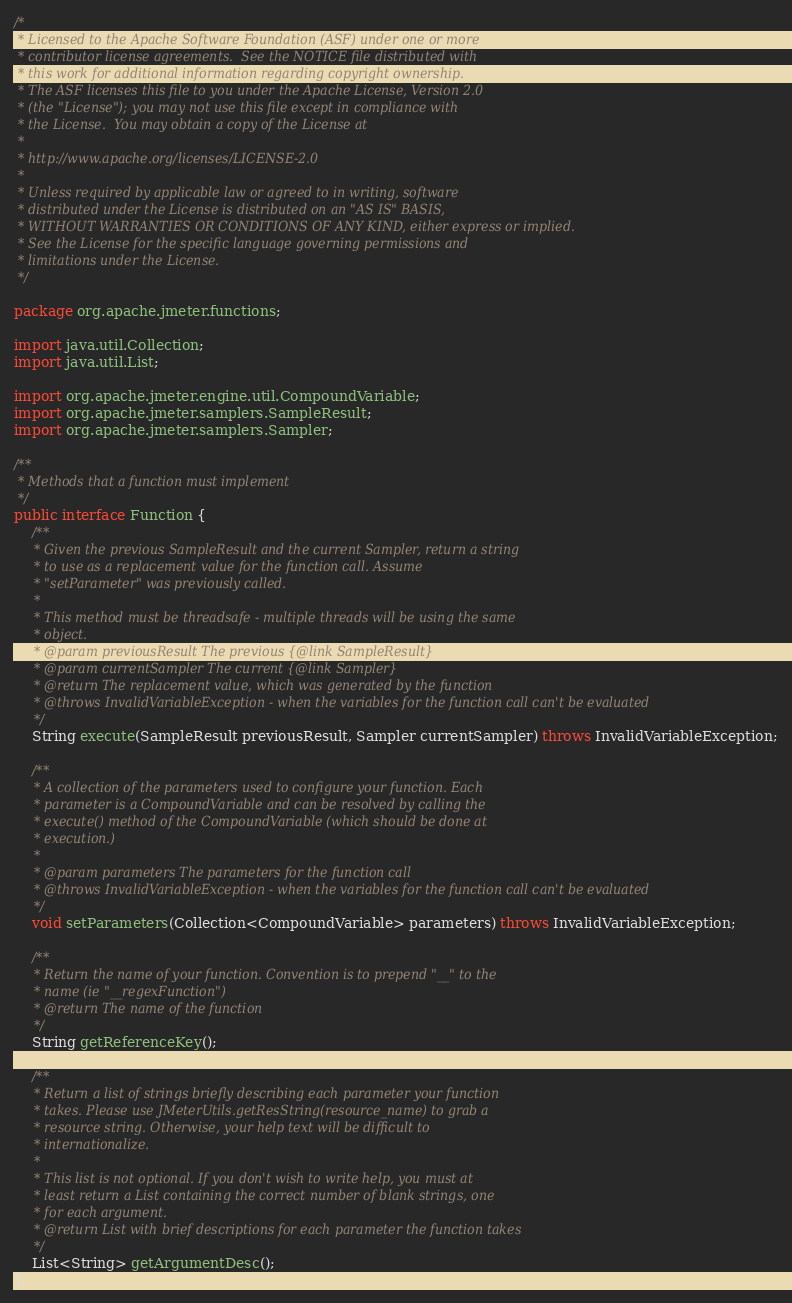<code> <loc_0><loc_0><loc_500><loc_500><_Java_>/*
 * Licensed to the Apache Software Foundation (ASF) under one or more
 * contributor license agreements.  See the NOTICE file distributed with
 * this work for additional information regarding copyright ownership.
 * The ASF licenses this file to you under the Apache License, Version 2.0
 * (the "License"); you may not use this file except in compliance with
 * the License.  You may obtain a copy of the License at
 *
 * http://www.apache.org/licenses/LICENSE-2.0
 *
 * Unless required by applicable law or agreed to in writing, software
 * distributed under the License is distributed on an "AS IS" BASIS,
 * WITHOUT WARRANTIES OR CONDITIONS OF ANY KIND, either express or implied.
 * See the License for the specific language governing permissions and
 * limitations under the License.
 */

package org.apache.jmeter.functions;

import java.util.Collection;
import java.util.List;

import org.apache.jmeter.engine.util.CompoundVariable;
import org.apache.jmeter.samplers.SampleResult;
import org.apache.jmeter.samplers.Sampler;

/**
 * Methods that a function must implement
 */
public interface Function {
    /**
     * Given the previous SampleResult and the current Sampler, return a string
     * to use as a replacement value for the function call. Assume
     * "setParameter" was previously called.
     *
     * This method must be threadsafe - multiple threads will be using the same
     * object.
     * @param previousResult The previous {@link SampleResult}
     * @param currentSampler The current {@link Sampler}
     * @return The replacement value, which was generated by the function
     * @throws InvalidVariableException - when the variables for the function call can't be evaluated
     */
    String execute(SampleResult previousResult, Sampler currentSampler) throws InvalidVariableException;

    /**
     * A collection of the parameters used to configure your function. Each
     * parameter is a CompoundVariable and can be resolved by calling the
     * execute() method of the CompoundVariable (which should be done at
     * execution.)
     *
     * @param parameters The parameters for the function call
     * @throws InvalidVariableException - when the variables for the function call can't be evaluated
     */
    void setParameters(Collection<CompoundVariable> parameters) throws InvalidVariableException;

    /**
     * Return the name of your function. Convention is to prepend "__" to the
     * name (ie "__regexFunction")
     * @return The name of the function
     */
    String getReferenceKey();

    /**
     * Return a list of strings briefly describing each parameter your function
     * takes. Please use JMeterUtils.getResString(resource_name) to grab a
     * resource string. Otherwise, your help text will be difficult to
     * internationalize.
     *
     * This list is not optional. If you don't wish to write help, you must at
     * least return a List containing the correct number of blank strings, one
     * for each argument.
     * @return List with brief descriptions for each parameter the function takes
     */
    List<String> getArgumentDesc();
}
</code> 